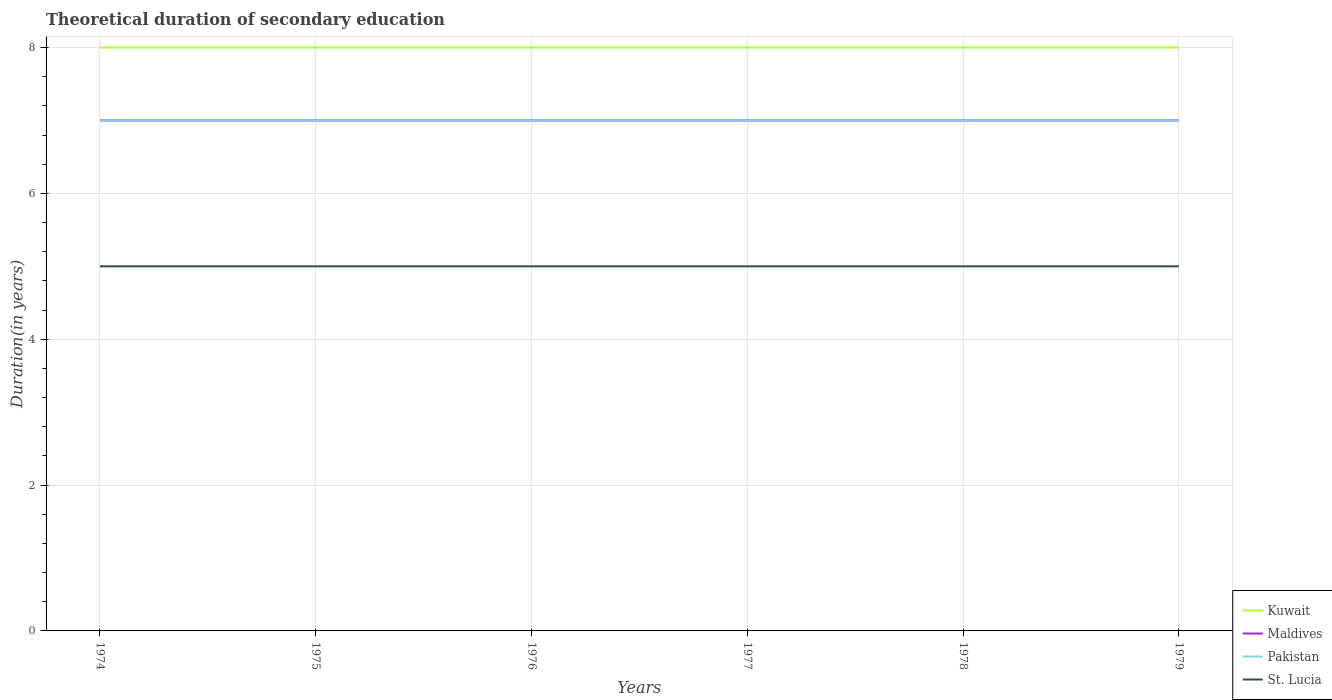Does the line corresponding to Kuwait intersect with the line corresponding to Pakistan?
Make the answer very short. No. Across all years, what is the maximum total theoretical duration of secondary education in Pakistan?
Ensure brevity in your answer.  7. In which year was the total theoretical duration of secondary education in St. Lucia maximum?
Provide a short and direct response. 1974. What is the difference between the highest and the lowest total theoretical duration of secondary education in Maldives?
Make the answer very short. 0. How many years are there in the graph?
Your answer should be very brief. 6. Are the values on the major ticks of Y-axis written in scientific E-notation?
Offer a very short reply. No. Does the graph contain any zero values?
Offer a very short reply. No. Does the graph contain grids?
Make the answer very short. Yes. Where does the legend appear in the graph?
Your response must be concise. Bottom right. How many legend labels are there?
Your answer should be very brief. 4. How are the legend labels stacked?
Make the answer very short. Vertical. What is the title of the graph?
Your response must be concise. Theoretical duration of secondary education. Does "Kazakhstan" appear as one of the legend labels in the graph?
Your answer should be compact. No. What is the label or title of the Y-axis?
Give a very brief answer. Duration(in years). What is the Duration(in years) of St. Lucia in 1974?
Give a very brief answer. 5. What is the Duration(in years) of Kuwait in 1975?
Offer a terse response. 8. What is the Duration(in years) in Pakistan in 1975?
Your answer should be very brief. 7. What is the Duration(in years) of Maldives in 1976?
Keep it short and to the point. 7. What is the Duration(in years) of Kuwait in 1977?
Your answer should be very brief. 8. What is the Duration(in years) of Maldives in 1977?
Your answer should be compact. 7. What is the Duration(in years) of Pakistan in 1977?
Your answer should be very brief. 7. What is the Duration(in years) of St. Lucia in 1977?
Ensure brevity in your answer.  5. What is the Duration(in years) of Kuwait in 1978?
Offer a terse response. 8. What is the Duration(in years) of Maldives in 1978?
Offer a very short reply. 7. What is the Duration(in years) in St. Lucia in 1978?
Offer a very short reply. 5. Across all years, what is the maximum Duration(in years) in Maldives?
Offer a very short reply. 7. Across all years, what is the minimum Duration(in years) of Kuwait?
Offer a very short reply. 8. Across all years, what is the minimum Duration(in years) of Maldives?
Give a very brief answer. 7. Across all years, what is the minimum Duration(in years) of St. Lucia?
Offer a very short reply. 5. What is the total Duration(in years) in Kuwait in the graph?
Give a very brief answer. 48. What is the total Duration(in years) of Maldives in the graph?
Make the answer very short. 42. What is the total Duration(in years) of Pakistan in the graph?
Offer a terse response. 42. What is the difference between the Duration(in years) of Kuwait in 1974 and that in 1975?
Offer a very short reply. 0. What is the difference between the Duration(in years) of Maldives in 1974 and that in 1975?
Make the answer very short. 0. What is the difference between the Duration(in years) of Kuwait in 1974 and that in 1976?
Provide a succinct answer. 0. What is the difference between the Duration(in years) of Maldives in 1974 and that in 1976?
Offer a very short reply. 0. What is the difference between the Duration(in years) in Maldives in 1974 and that in 1977?
Provide a succinct answer. 0. What is the difference between the Duration(in years) of Pakistan in 1974 and that in 1977?
Provide a succinct answer. 0. What is the difference between the Duration(in years) of St. Lucia in 1974 and that in 1977?
Give a very brief answer. 0. What is the difference between the Duration(in years) in Kuwait in 1974 and that in 1978?
Make the answer very short. 0. What is the difference between the Duration(in years) in Maldives in 1974 and that in 1978?
Give a very brief answer. 0. What is the difference between the Duration(in years) in Pakistan in 1974 and that in 1978?
Your response must be concise. 0. What is the difference between the Duration(in years) in St. Lucia in 1974 and that in 1978?
Your answer should be compact. 0. What is the difference between the Duration(in years) in Kuwait in 1974 and that in 1979?
Keep it short and to the point. 0. What is the difference between the Duration(in years) in St. Lucia in 1974 and that in 1979?
Offer a terse response. 0. What is the difference between the Duration(in years) of Pakistan in 1975 and that in 1976?
Ensure brevity in your answer.  0. What is the difference between the Duration(in years) of Kuwait in 1975 and that in 1977?
Offer a very short reply. 0. What is the difference between the Duration(in years) in Maldives in 1975 and that in 1977?
Give a very brief answer. 0. What is the difference between the Duration(in years) of Kuwait in 1975 and that in 1978?
Provide a succinct answer. 0. What is the difference between the Duration(in years) of Maldives in 1975 and that in 1978?
Your response must be concise. 0. What is the difference between the Duration(in years) of Pakistan in 1975 and that in 1978?
Provide a succinct answer. 0. What is the difference between the Duration(in years) of St. Lucia in 1975 and that in 1978?
Give a very brief answer. 0. What is the difference between the Duration(in years) of Kuwait in 1975 and that in 1979?
Your answer should be compact. 0. What is the difference between the Duration(in years) in Maldives in 1975 and that in 1979?
Your response must be concise. 0. What is the difference between the Duration(in years) of Pakistan in 1975 and that in 1979?
Ensure brevity in your answer.  0. What is the difference between the Duration(in years) of St. Lucia in 1975 and that in 1979?
Provide a short and direct response. 0. What is the difference between the Duration(in years) of St. Lucia in 1976 and that in 1977?
Offer a terse response. 0. What is the difference between the Duration(in years) in Kuwait in 1976 and that in 1978?
Provide a succinct answer. 0. What is the difference between the Duration(in years) in Maldives in 1976 and that in 1978?
Offer a terse response. 0. What is the difference between the Duration(in years) in Kuwait in 1976 and that in 1979?
Your response must be concise. 0. What is the difference between the Duration(in years) of Maldives in 1976 and that in 1979?
Ensure brevity in your answer.  0. What is the difference between the Duration(in years) of Pakistan in 1976 and that in 1979?
Provide a short and direct response. 0. What is the difference between the Duration(in years) in Kuwait in 1977 and that in 1979?
Provide a succinct answer. 0. What is the difference between the Duration(in years) in Maldives in 1977 and that in 1979?
Keep it short and to the point. 0. What is the difference between the Duration(in years) of Kuwait in 1978 and that in 1979?
Your response must be concise. 0. What is the difference between the Duration(in years) in Maldives in 1978 and that in 1979?
Give a very brief answer. 0. What is the difference between the Duration(in years) in Pakistan in 1978 and that in 1979?
Give a very brief answer. 0. What is the difference between the Duration(in years) in St. Lucia in 1978 and that in 1979?
Your answer should be compact. 0. What is the difference between the Duration(in years) of Kuwait in 1974 and the Duration(in years) of Maldives in 1975?
Your answer should be compact. 1. What is the difference between the Duration(in years) of Kuwait in 1974 and the Duration(in years) of Pakistan in 1975?
Offer a very short reply. 1. What is the difference between the Duration(in years) of Kuwait in 1974 and the Duration(in years) of St. Lucia in 1975?
Your answer should be very brief. 3. What is the difference between the Duration(in years) of Maldives in 1974 and the Duration(in years) of St. Lucia in 1975?
Provide a succinct answer. 2. What is the difference between the Duration(in years) in Kuwait in 1974 and the Duration(in years) in Pakistan in 1976?
Your answer should be compact. 1. What is the difference between the Duration(in years) of Maldives in 1974 and the Duration(in years) of Pakistan in 1976?
Your answer should be very brief. 0. What is the difference between the Duration(in years) of Kuwait in 1974 and the Duration(in years) of Pakistan in 1977?
Your answer should be compact. 1. What is the difference between the Duration(in years) of Kuwait in 1974 and the Duration(in years) of St. Lucia in 1977?
Keep it short and to the point. 3. What is the difference between the Duration(in years) in Maldives in 1974 and the Duration(in years) in Pakistan in 1977?
Your answer should be very brief. 0. What is the difference between the Duration(in years) in Pakistan in 1974 and the Duration(in years) in St. Lucia in 1977?
Your answer should be very brief. 2. What is the difference between the Duration(in years) of Kuwait in 1974 and the Duration(in years) of Maldives in 1978?
Offer a terse response. 1. What is the difference between the Duration(in years) of Maldives in 1974 and the Duration(in years) of Pakistan in 1978?
Offer a terse response. 0. What is the difference between the Duration(in years) of Maldives in 1974 and the Duration(in years) of St. Lucia in 1978?
Give a very brief answer. 2. What is the difference between the Duration(in years) in Pakistan in 1974 and the Duration(in years) in St. Lucia in 1978?
Provide a short and direct response. 2. What is the difference between the Duration(in years) in Kuwait in 1974 and the Duration(in years) in Maldives in 1979?
Your answer should be compact. 1. What is the difference between the Duration(in years) in Maldives in 1974 and the Duration(in years) in Pakistan in 1979?
Your answer should be very brief. 0. What is the difference between the Duration(in years) in Maldives in 1974 and the Duration(in years) in St. Lucia in 1979?
Provide a succinct answer. 2. What is the difference between the Duration(in years) of Kuwait in 1975 and the Duration(in years) of Maldives in 1976?
Make the answer very short. 1. What is the difference between the Duration(in years) in Kuwait in 1975 and the Duration(in years) in Pakistan in 1976?
Keep it short and to the point. 1. What is the difference between the Duration(in years) in Kuwait in 1975 and the Duration(in years) in St. Lucia in 1976?
Ensure brevity in your answer.  3. What is the difference between the Duration(in years) in Maldives in 1975 and the Duration(in years) in Pakistan in 1976?
Your answer should be very brief. 0. What is the difference between the Duration(in years) in Pakistan in 1975 and the Duration(in years) in St. Lucia in 1976?
Ensure brevity in your answer.  2. What is the difference between the Duration(in years) in Kuwait in 1975 and the Duration(in years) in Maldives in 1977?
Make the answer very short. 1. What is the difference between the Duration(in years) in Kuwait in 1975 and the Duration(in years) in Pakistan in 1977?
Offer a terse response. 1. What is the difference between the Duration(in years) of Kuwait in 1975 and the Duration(in years) of Maldives in 1979?
Your answer should be very brief. 1. What is the difference between the Duration(in years) in Pakistan in 1975 and the Duration(in years) in St. Lucia in 1979?
Provide a succinct answer. 2. What is the difference between the Duration(in years) in Kuwait in 1976 and the Duration(in years) in St. Lucia in 1977?
Ensure brevity in your answer.  3. What is the difference between the Duration(in years) in Kuwait in 1976 and the Duration(in years) in Pakistan in 1978?
Ensure brevity in your answer.  1. What is the difference between the Duration(in years) in Kuwait in 1976 and the Duration(in years) in St. Lucia in 1978?
Make the answer very short. 3. What is the difference between the Duration(in years) of Maldives in 1976 and the Duration(in years) of Pakistan in 1979?
Offer a terse response. 0. What is the difference between the Duration(in years) of Maldives in 1976 and the Duration(in years) of St. Lucia in 1979?
Give a very brief answer. 2. What is the difference between the Duration(in years) in Pakistan in 1976 and the Duration(in years) in St. Lucia in 1979?
Provide a short and direct response. 2. What is the difference between the Duration(in years) of Kuwait in 1977 and the Duration(in years) of St. Lucia in 1978?
Your answer should be compact. 3. What is the difference between the Duration(in years) in Maldives in 1977 and the Duration(in years) in Pakistan in 1978?
Give a very brief answer. 0. What is the difference between the Duration(in years) of Pakistan in 1977 and the Duration(in years) of St. Lucia in 1978?
Provide a succinct answer. 2. What is the difference between the Duration(in years) of Kuwait in 1977 and the Duration(in years) of Pakistan in 1979?
Give a very brief answer. 1. What is the difference between the Duration(in years) of Pakistan in 1977 and the Duration(in years) of St. Lucia in 1979?
Provide a succinct answer. 2. What is the difference between the Duration(in years) of Kuwait in 1978 and the Duration(in years) of Maldives in 1979?
Your answer should be compact. 1. What is the difference between the Duration(in years) in Kuwait in 1978 and the Duration(in years) in Pakistan in 1979?
Make the answer very short. 1. What is the difference between the Duration(in years) of Kuwait in 1978 and the Duration(in years) of St. Lucia in 1979?
Offer a very short reply. 3. What is the difference between the Duration(in years) of Pakistan in 1978 and the Duration(in years) of St. Lucia in 1979?
Your response must be concise. 2. What is the average Duration(in years) in Pakistan per year?
Make the answer very short. 7. What is the average Duration(in years) of St. Lucia per year?
Give a very brief answer. 5. In the year 1974, what is the difference between the Duration(in years) in Kuwait and Duration(in years) in Maldives?
Ensure brevity in your answer.  1. In the year 1974, what is the difference between the Duration(in years) of Kuwait and Duration(in years) of Pakistan?
Ensure brevity in your answer.  1. In the year 1974, what is the difference between the Duration(in years) of Maldives and Duration(in years) of Pakistan?
Your response must be concise. 0. In the year 1974, what is the difference between the Duration(in years) of Maldives and Duration(in years) of St. Lucia?
Provide a short and direct response. 2. In the year 1974, what is the difference between the Duration(in years) of Pakistan and Duration(in years) of St. Lucia?
Make the answer very short. 2. In the year 1975, what is the difference between the Duration(in years) of Kuwait and Duration(in years) of St. Lucia?
Offer a very short reply. 3. In the year 1976, what is the difference between the Duration(in years) in Kuwait and Duration(in years) in Maldives?
Ensure brevity in your answer.  1. In the year 1976, what is the difference between the Duration(in years) of Kuwait and Duration(in years) of St. Lucia?
Your answer should be compact. 3. In the year 1976, what is the difference between the Duration(in years) of Maldives and Duration(in years) of Pakistan?
Make the answer very short. 0. In the year 1976, what is the difference between the Duration(in years) in Pakistan and Duration(in years) in St. Lucia?
Make the answer very short. 2. In the year 1977, what is the difference between the Duration(in years) in Kuwait and Duration(in years) in Pakistan?
Provide a short and direct response. 1. In the year 1977, what is the difference between the Duration(in years) in Kuwait and Duration(in years) in St. Lucia?
Give a very brief answer. 3. In the year 1977, what is the difference between the Duration(in years) in Maldives and Duration(in years) in Pakistan?
Your answer should be very brief. 0. In the year 1977, what is the difference between the Duration(in years) in Maldives and Duration(in years) in St. Lucia?
Provide a short and direct response. 2. In the year 1977, what is the difference between the Duration(in years) in Pakistan and Duration(in years) in St. Lucia?
Ensure brevity in your answer.  2. In the year 1978, what is the difference between the Duration(in years) in Kuwait and Duration(in years) in Maldives?
Make the answer very short. 1. In the year 1978, what is the difference between the Duration(in years) of Kuwait and Duration(in years) of St. Lucia?
Offer a very short reply. 3. In the year 1978, what is the difference between the Duration(in years) in Pakistan and Duration(in years) in St. Lucia?
Your response must be concise. 2. In the year 1979, what is the difference between the Duration(in years) in Kuwait and Duration(in years) in Maldives?
Your answer should be very brief. 1. In the year 1979, what is the difference between the Duration(in years) of Kuwait and Duration(in years) of St. Lucia?
Your answer should be very brief. 3. In the year 1979, what is the difference between the Duration(in years) in Maldives and Duration(in years) in St. Lucia?
Make the answer very short. 2. In the year 1979, what is the difference between the Duration(in years) of Pakistan and Duration(in years) of St. Lucia?
Your response must be concise. 2. What is the ratio of the Duration(in years) of Kuwait in 1974 to that in 1975?
Your answer should be very brief. 1. What is the ratio of the Duration(in years) of Kuwait in 1974 to that in 1976?
Give a very brief answer. 1. What is the ratio of the Duration(in years) in Maldives in 1974 to that in 1976?
Provide a short and direct response. 1. What is the ratio of the Duration(in years) of Pakistan in 1974 to that in 1976?
Your answer should be compact. 1. What is the ratio of the Duration(in years) of St. Lucia in 1974 to that in 1977?
Your response must be concise. 1. What is the ratio of the Duration(in years) of Pakistan in 1974 to that in 1978?
Your answer should be very brief. 1. What is the ratio of the Duration(in years) of St. Lucia in 1974 to that in 1978?
Your answer should be compact. 1. What is the ratio of the Duration(in years) in Maldives in 1974 to that in 1979?
Your answer should be compact. 1. What is the ratio of the Duration(in years) in St. Lucia in 1974 to that in 1979?
Your answer should be compact. 1. What is the ratio of the Duration(in years) in St. Lucia in 1975 to that in 1976?
Your answer should be very brief. 1. What is the ratio of the Duration(in years) of Kuwait in 1975 to that in 1977?
Your answer should be compact. 1. What is the ratio of the Duration(in years) in Maldives in 1975 to that in 1977?
Give a very brief answer. 1. What is the ratio of the Duration(in years) of St. Lucia in 1975 to that in 1977?
Provide a short and direct response. 1. What is the ratio of the Duration(in years) in Maldives in 1975 to that in 1978?
Your answer should be very brief. 1. What is the ratio of the Duration(in years) of Maldives in 1975 to that in 1979?
Your answer should be compact. 1. What is the ratio of the Duration(in years) in St. Lucia in 1975 to that in 1979?
Your answer should be very brief. 1. What is the ratio of the Duration(in years) of Kuwait in 1976 to that in 1977?
Your response must be concise. 1. What is the ratio of the Duration(in years) of Pakistan in 1976 to that in 1977?
Ensure brevity in your answer.  1. What is the ratio of the Duration(in years) of Kuwait in 1976 to that in 1978?
Ensure brevity in your answer.  1. What is the ratio of the Duration(in years) of Maldives in 1976 to that in 1978?
Offer a terse response. 1. What is the ratio of the Duration(in years) in Pakistan in 1976 to that in 1978?
Ensure brevity in your answer.  1. What is the ratio of the Duration(in years) of Maldives in 1976 to that in 1979?
Ensure brevity in your answer.  1. What is the ratio of the Duration(in years) of St. Lucia in 1977 to that in 1978?
Provide a short and direct response. 1. What is the ratio of the Duration(in years) of Kuwait in 1977 to that in 1979?
Provide a short and direct response. 1. What is the ratio of the Duration(in years) in Maldives in 1977 to that in 1979?
Your answer should be compact. 1. What is the ratio of the Duration(in years) in Pakistan in 1977 to that in 1979?
Give a very brief answer. 1. What is the ratio of the Duration(in years) of St. Lucia in 1977 to that in 1979?
Your answer should be very brief. 1. What is the ratio of the Duration(in years) of Kuwait in 1978 to that in 1979?
Provide a succinct answer. 1. What is the ratio of the Duration(in years) of Pakistan in 1978 to that in 1979?
Keep it short and to the point. 1. What is the difference between the highest and the second highest Duration(in years) of St. Lucia?
Ensure brevity in your answer.  0. What is the difference between the highest and the lowest Duration(in years) of Maldives?
Make the answer very short. 0. 